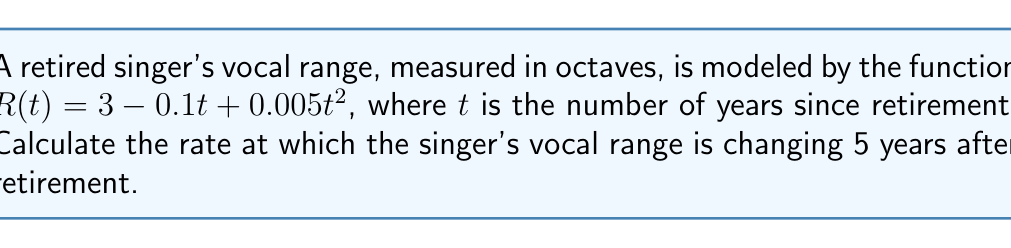Help me with this question. To find the rate of change in the singer's vocal range, we need to calculate the derivative of the given function and evaluate it at $t = 5$.

Step 1: Given function
$$R(t) = 3 - 0.1t + 0.005t^2$$

Step 2: Calculate the derivative
$$\frac{dR}{dt} = -0.1 + 0.01t$$

Step 3: Evaluate the derivative at $t = 5$
$$\frac{dR}{dt}\big|_{t=5} = -0.1 + 0.01(5)$$
$$\frac{dR}{dt}\big|_{t=5} = -0.1 + 0.05$$
$$\frac{dR}{dt}\big|_{t=5} = -0.05$$

The negative value indicates that the vocal range is decreasing at this point in time.
Answer: $-0.05$ octaves per year 